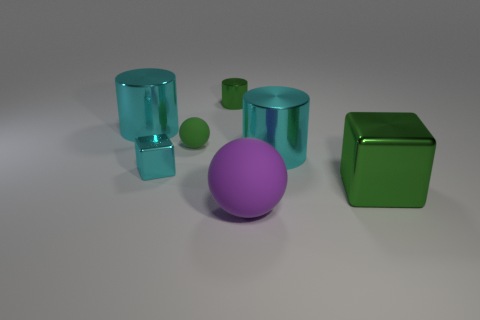Subtract all blue cylinders. Subtract all cyan spheres. How many cylinders are left? 3 Add 3 tiny spheres. How many objects exist? 10 Subtract all cylinders. How many objects are left? 4 Add 7 tiny green cylinders. How many tiny green cylinders are left? 8 Add 7 large red shiny objects. How many large red shiny objects exist? 7 Subtract 1 cyan blocks. How many objects are left? 6 Subtract all green matte objects. Subtract all green blocks. How many objects are left? 5 